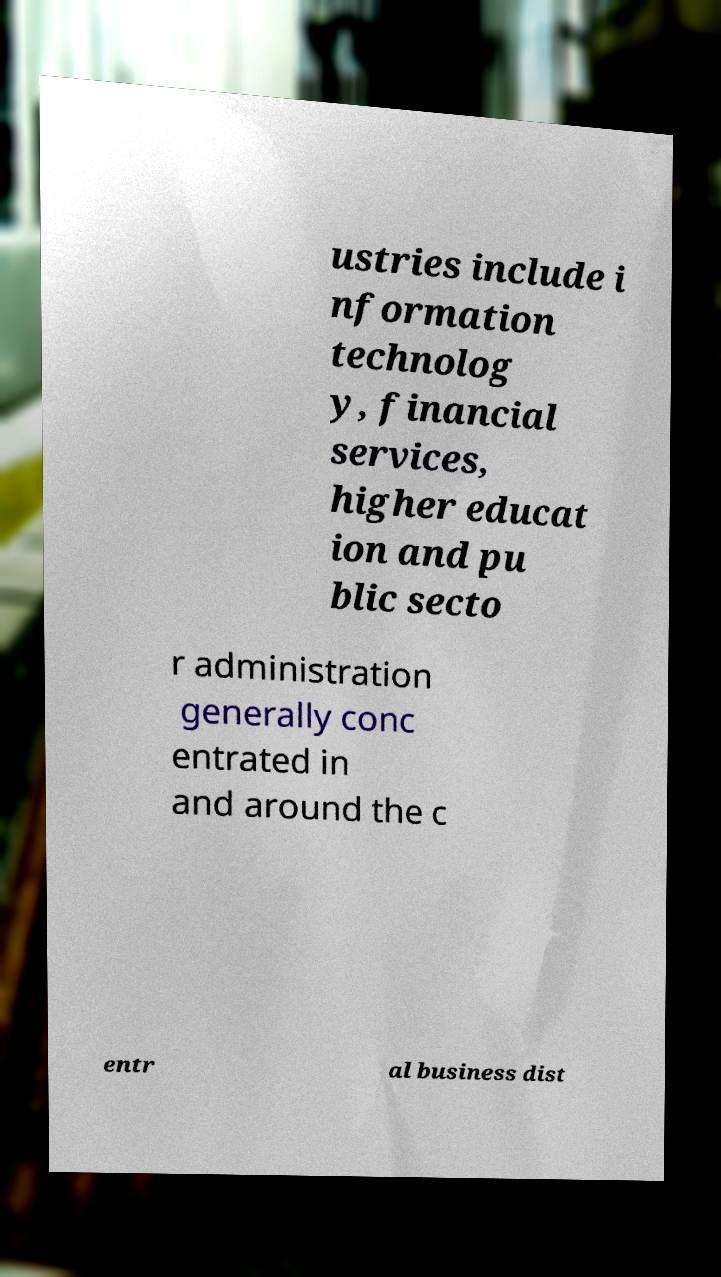Please identify and transcribe the text found in this image. ustries include i nformation technolog y, financial services, higher educat ion and pu blic secto r administration generally conc entrated in and around the c entr al business dist 